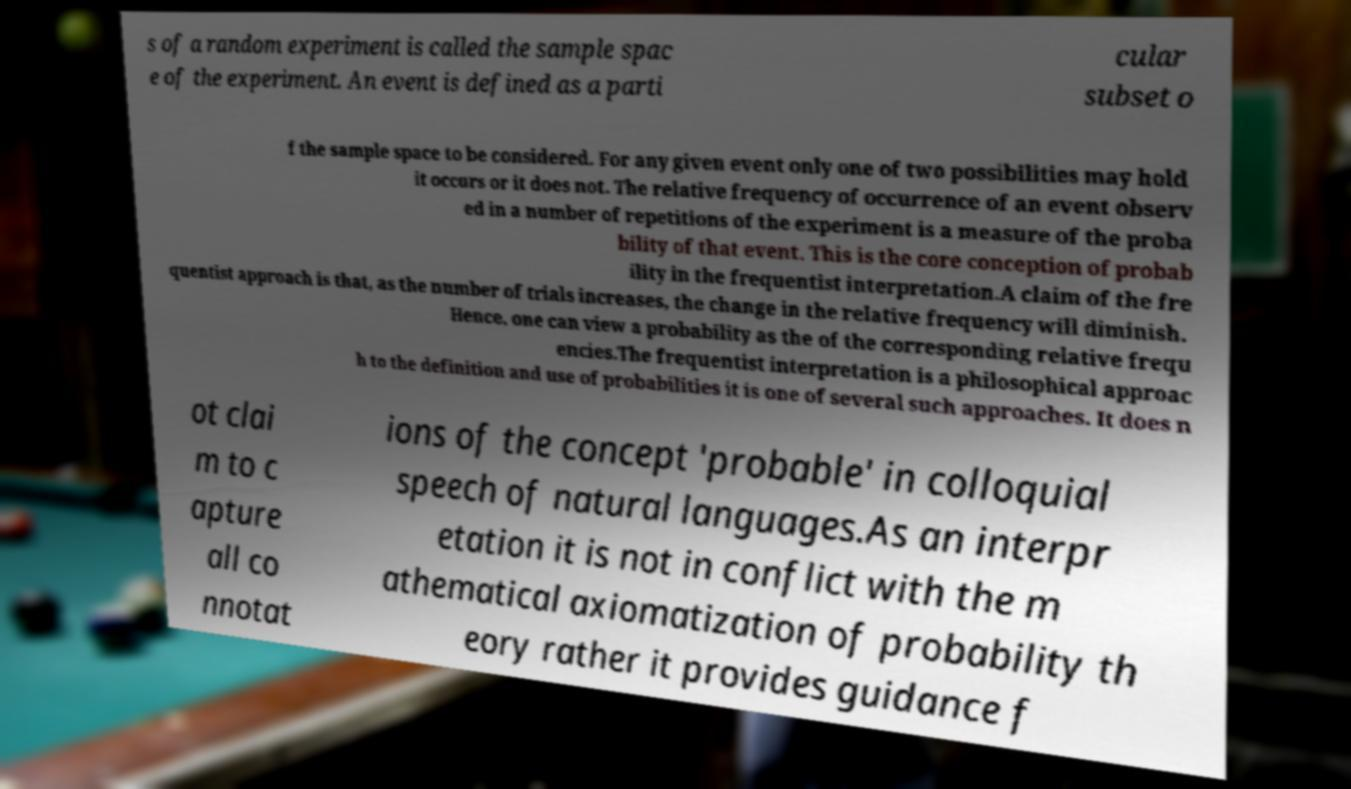Please identify and transcribe the text found in this image. s of a random experiment is called the sample spac e of the experiment. An event is defined as a parti cular subset o f the sample space to be considered. For any given event only one of two possibilities may hold it occurs or it does not. The relative frequency of occurrence of an event observ ed in a number of repetitions of the experiment is a measure of the proba bility of that event. This is the core conception of probab ility in the frequentist interpretation.A claim of the fre quentist approach is that, as the number of trials increases, the change in the relative frequency will diminish. Hence, one can view a probability as the of the corresponding relative frequ encies.The frequentist interpretation is a philosophical approac h to the definition and use of probabilities it is one of several such approaches. It does n ot clai m to c apture all co nnotat ions of the concept 'probable' in colloquial speech of natural languages.As an interpr etation it is not in conflict with the m athematical axiomatization of probability th eory rather it provides guidance f 